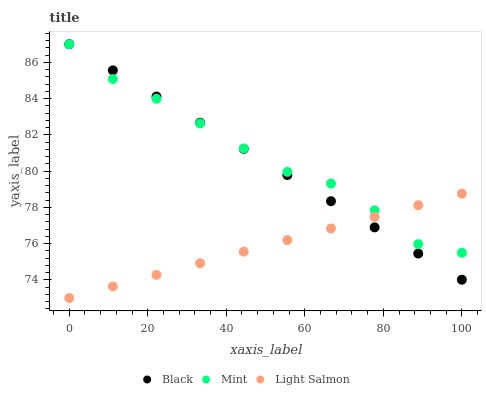Does Light Salmon have the minimum area under the curve?
Answer yes or no. Yes. Does Mint have the maximum area under the curve?
Answer yes or no. Yes. Does Black have the minimum area under the curve?
Answer yes or no. No. Does Black have the maximum area under the curve?
Answer yes or no. No. Is Black the smoothest?
Answer yes or no. Yes. Is Mint the roughest?
Answer yes or no. Yes. Is Light Salmon the smoothest?
Answer yes or no. No. Is Light Salmon the roughest?
Answer yes or no. No. Does Light Salmon have the lowest value?
Answer yes or no. Yes. Does Black have the lowest value?
Answer yes or no. No. Does Black have the highest value?
Answer yes or no. Yes. Does Light Salmon have the highest value?
Answer yes or no. No. Does Mint intersect Black?
Answer yes or no. Yes. Is Mint less than Black?
Answer yes or no. No. Is Mint greater than Black?
Answer yes or no. No. 